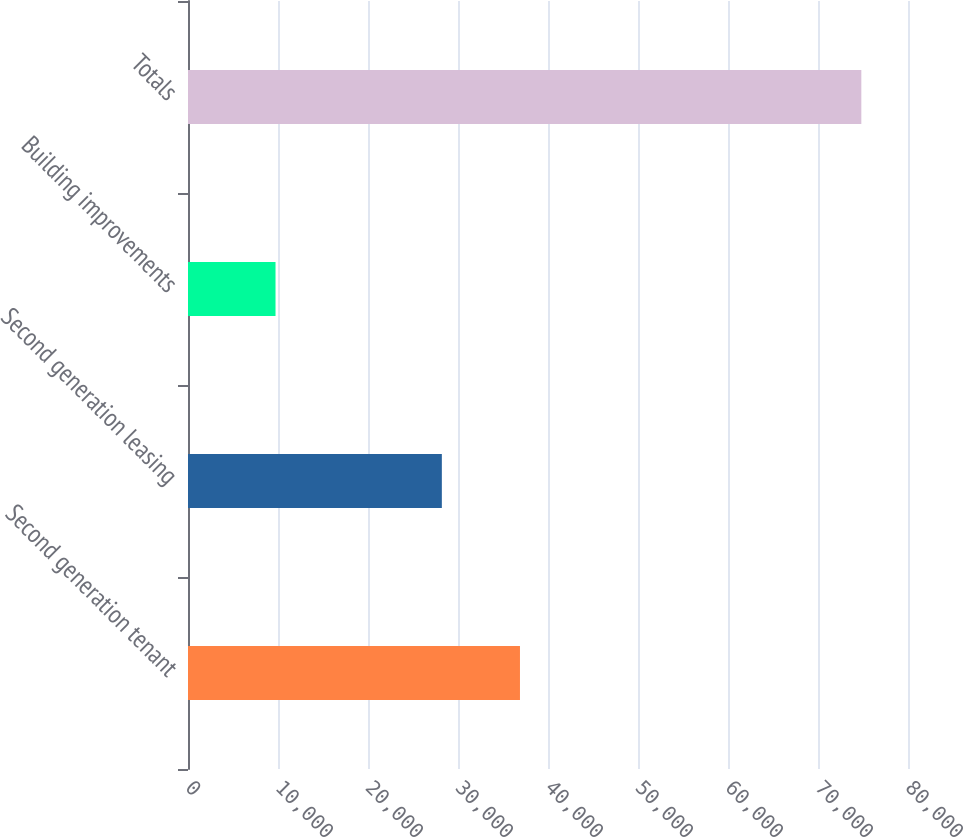Convert chart to OTSL. <chart><loc_0><loc_0><loc_500><loc_500><bar_chart><fcel>Second generation tenant<fcel>Second generation leasing<fcel>Building improvements<fcel>Totals<nl><fcel>36885<fcel>28205<fcel>9724<fcel>74814<nl></chart> 